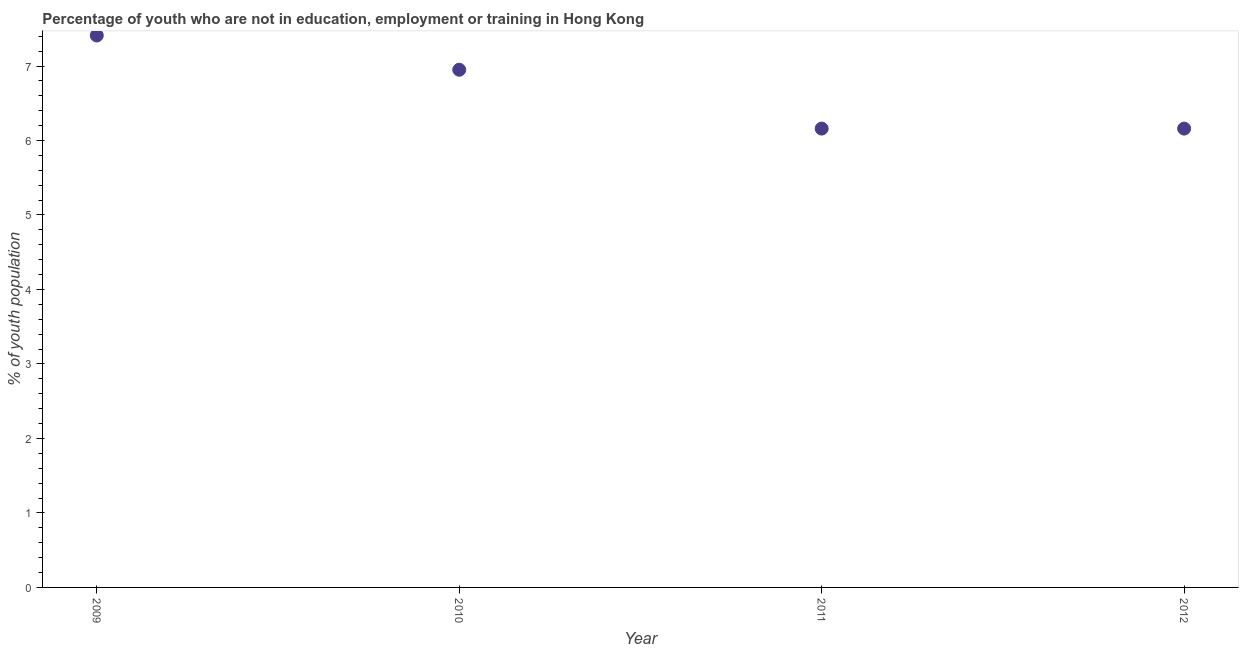What is the unemployed youth population in 2011?
Provide a short and direct response. 6.16. Across all years, what is the maximum unemployed youth population?
Provide a succinct answer. 7.41. Across all years, what is the minimum unemployed youth population?
Keep it short and to the point. 6.16. In which year was the unemployed youth population maximum?
Offer a terse response. 2009. In which year was the unemployed youth population minimum?
Offer a terse response. 2011. What is the sum of the unemployed youth population?
Ensure brevity in your answer.  26.68. What is the difference between the unemployed youth population in 2011 and 2012?
Offer a terse response. 0. What is the average unemployed youth population per year?
Provide a short and direct response. 6.67. What is the median unemployed youth population?
Your response must be concise. 6.55. In how many years, is the unemployed youth population greater than 0.8 %?
Your answer should be very brief. 4. Do a majority of the years between 2009 and 2010 (inclusive) have unemployed youth population greater than 2.4 %?
Offer a very short reply. Yes. Is the unemployed youth population in 2010 less than that in 2012?
Give a very brief answer. No. What is the difference between the highest and the second highest unemployed youth population?
Ensure brevity in your answer.  0.46. Is the sum of the unemployed youth population in 2010 and 2012 greater than the maximum unemployed youth population across all years?
Keep it short and to the point. Yes. What is the difference between the highest and the lowest unemployed youth population?
Give a very brief answer. 1.25. How many dotlines are there?
Provide a succinct answer. 1. Are the values on the major ticks of Y-axis written in scientific E-notation?
Offer a very short reply. No. Does the graph contain grids?
Ensure brevity in your answer.  No. What is the title of the graph?
Provide a succinct answer. Percentage of youth who are not in education, employment or training in Hong Kong. What is the label or title of the X-axis?
Your answer should be very brief. Year. What is the label or title of the Y-axis?
Your answer should be very brief. % of youth population. What is the % of youth population in 2009?
Provide a succinct answer. 7.41. What is the % of youth population in 2010?
Offer a terse response. 6.95. What is the % of youth population in 2011?
Give a very brief answer. 6.16. What is the % of youth population in 2012?
Provide a succinct answer. 6.16. What is the difference between the % of youth population in 2009 and 2010?
Offer a very short reply. 0.46. What is the difference between the % of youth population in 2009 and 2011?
Give a very brief answer. 1.25. What is the difference between the % of youth population in 2010 and 2011?
Your answer should be very brief. 0.79. What is the difference between the % of youth population in 2010 and 2012?
Keep it short and to the point. 0.79. What is the ratio of the % of youth population in 2009 to that in 2010?
Ensure brevity in your answer.  1.07. What is the ratio of the % of youth population in 2009 to that in 2011?
Your answer should be very brief. 1.2. What is the ratio of the % of youth population in 2009 to that in 2012?
Provide a short and direct response. 1.2. What is the ratio of the % of youth population in 2010 to that in 2011?
Your answer should be compact. 1.13. What is the ratio of the % of youth population in 2010 to that in 2012?
Your answer should be compact. 1.13. 